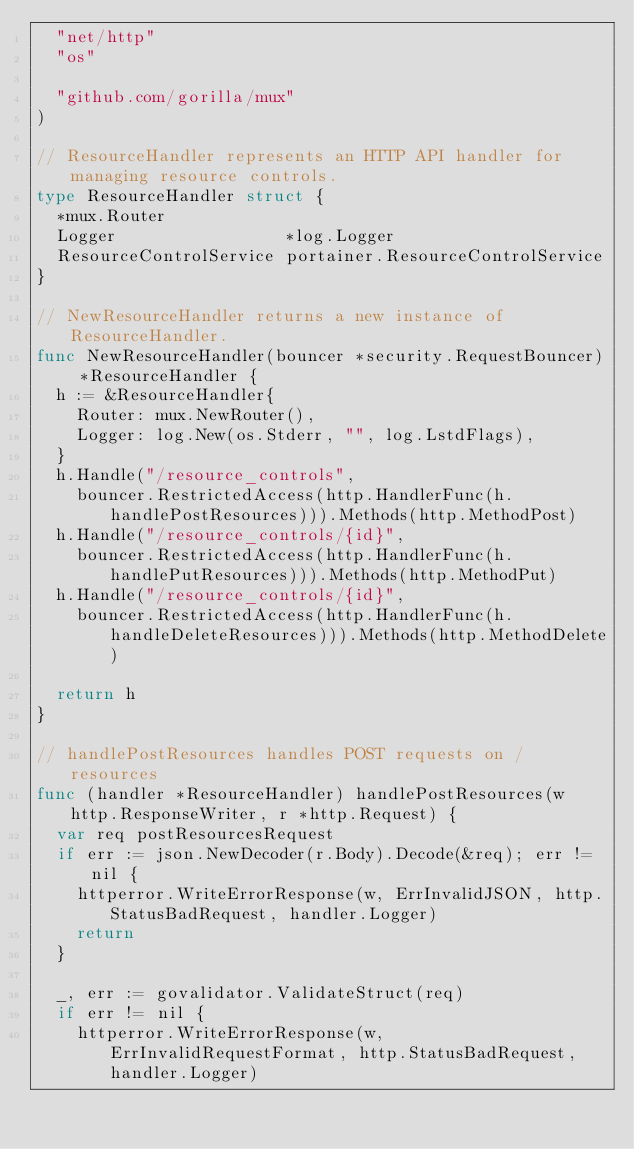Convert code to text. <code><loc_0><loc_0><loc_500><loc_500><_Go_>	"net/http"
	"os"

	"github.com/gorilla/mux"
)

// ResourceHandler represents an HTTP API handler for managing resource controls.
type ResourceHandler struct {
	*mux.Router
	Logger                 *log.Logger
	ResourceControlService portainer.ResourceControlService
}

// NewResourceHandler returns a new instance of ResourceHandler.
func NewResourceHandler(bouncer *security.RequestBouncer) *ResourceHandler {
	h := &ResourceHandler{
		Router: mux.NewRouter(),
		Logger: log.New(os.Stderr, "", log.LstdFlags),
	}
	h.Handle("/resource_controls",
		bouncer.RestrictedAccess(http.HandlerFunc(h.handlePostResources))).Methods(http.MethodPost)
	h.Handle("/resource_controls/{id}",
		bouncer.RestrictedAccess(http.HandlerFunc(h.handlePutResources))).Methods(http.MethodPut)
	h.Handle("/resource_controls/{id}",
		bouncer.RestrictedAccess(http.HandlerFunc(h.handleDeleteResources))).Methods(http.MethodDelete)

	return h
}

// handlePostResources handles POST requests on /resources
func (handler *ResourceHandler) handlePostResources(w http.ResponseWriter, r *http.Request) {
	var req postResourcesRequest
	if err := json.NewDecoder(r.Body).Decode(&req); err != nil {
		httperror.WriteErrorResponse(w, ErrInvalidJSON, http.StatusBadRequest, handler.Logger)
		return
	}

	_, err := govalidator.ValidateStruct(req)
	if err != nil {
		httperror.WriteErrorResponse(w, ErrInvalidRequestFormat, http.StatusBadRequest, handler.Logger)</code> 